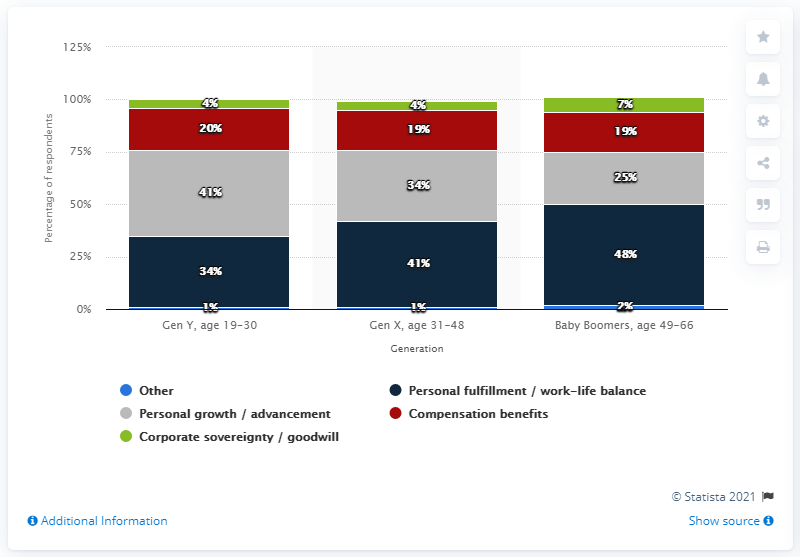Point out several critical features in this image. Of the Generation Y respondents surveyed, 20% listed compensation and benefits as the most important factor in their job search. 